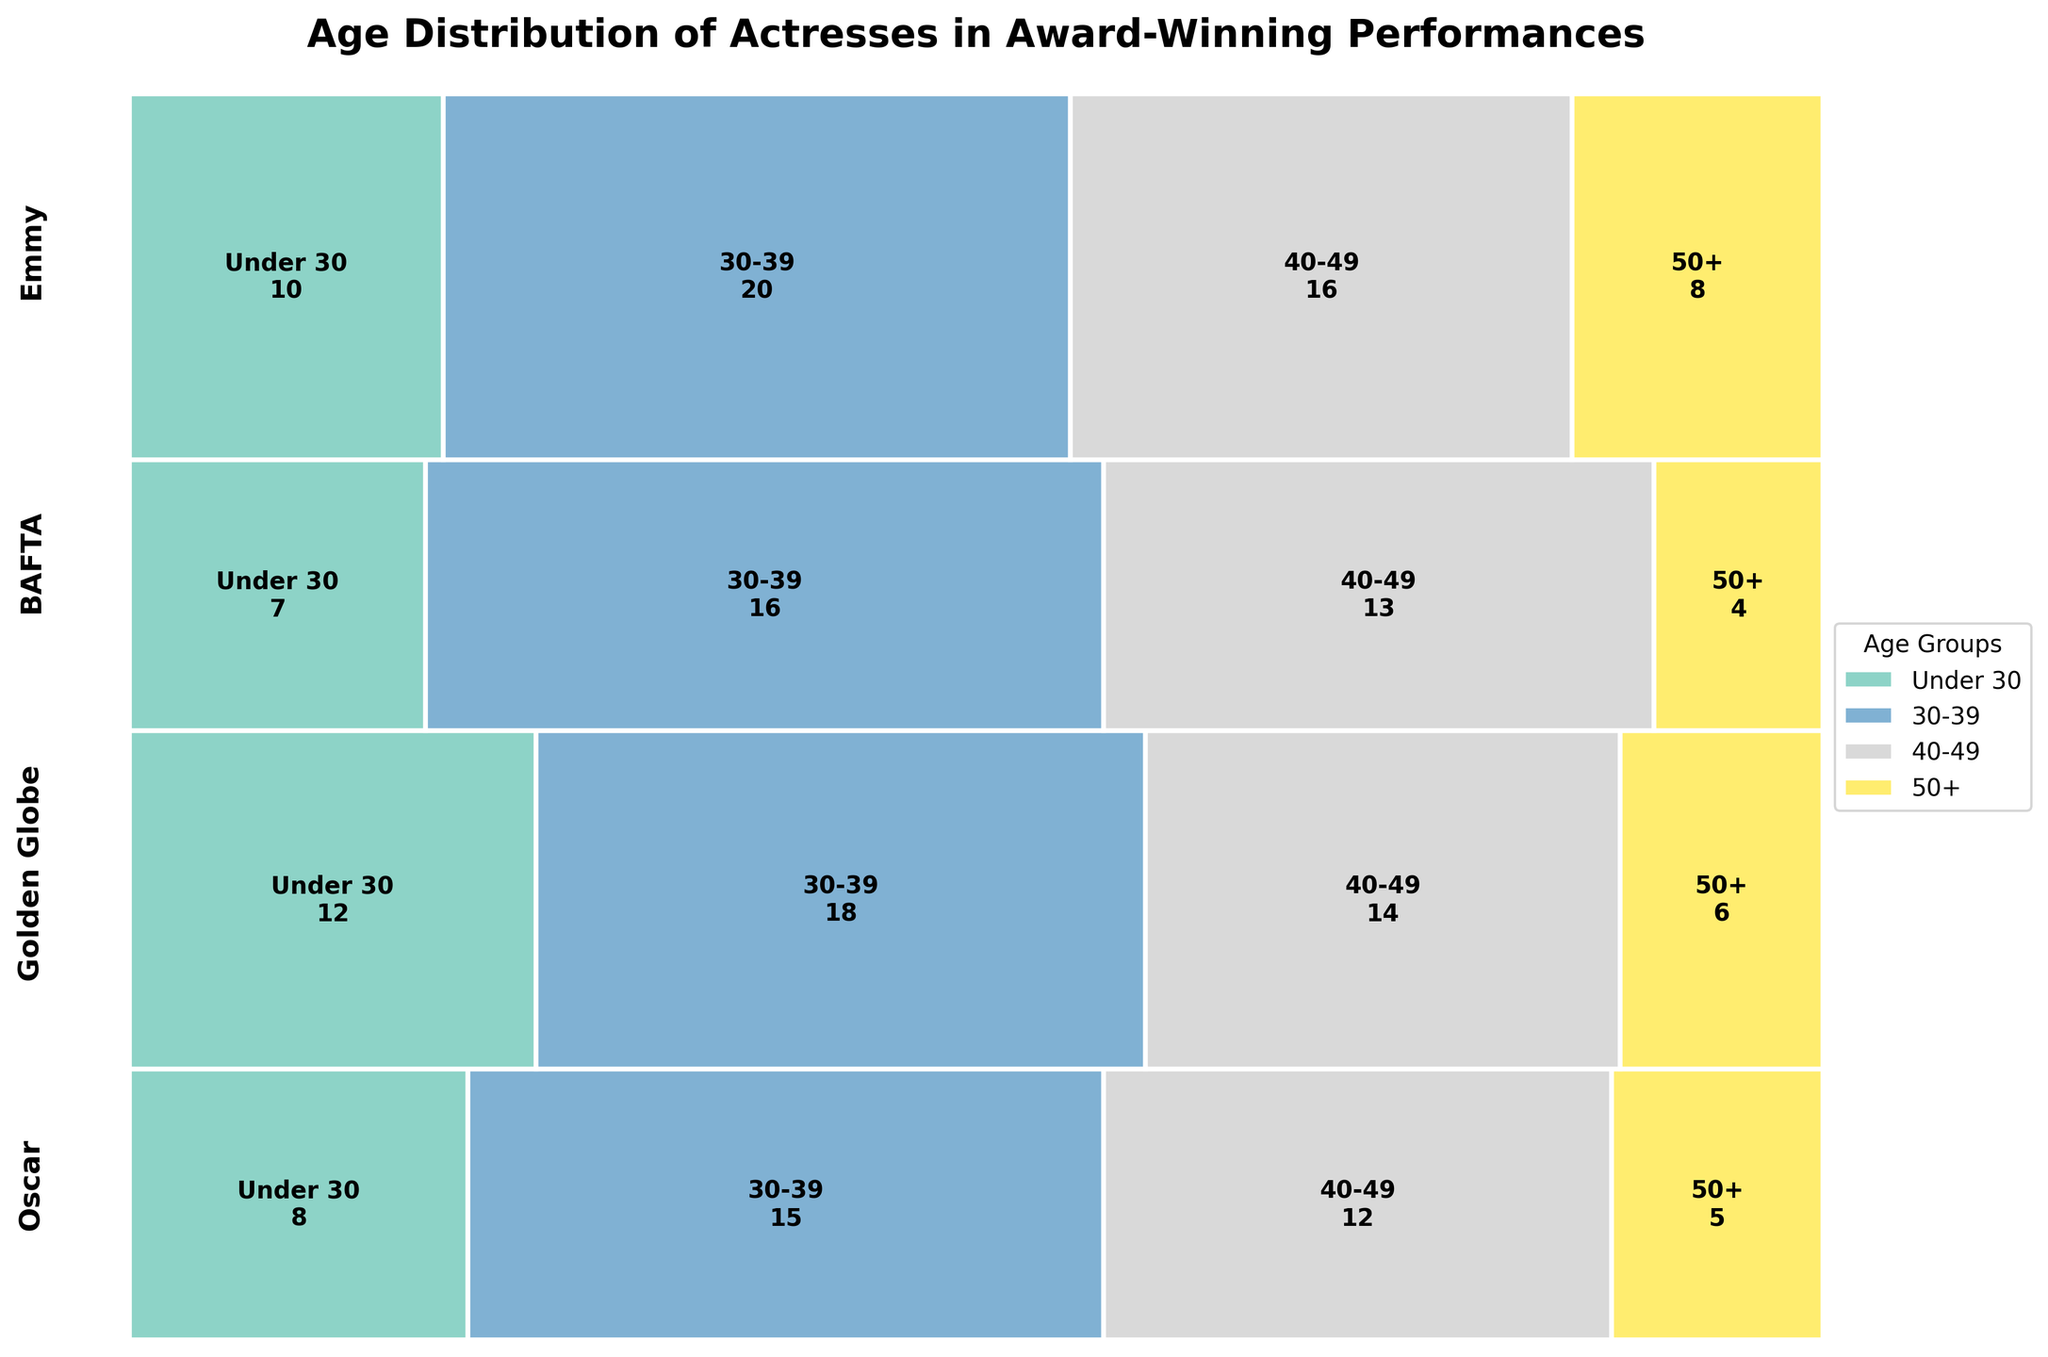How many actresses in the "Under 30" age group won Golden Globes? Look at the "Golden Globe" section of the mosaic plot and find the bar labeled "Under 30" within it. Inside this bar, you can see the count.
Answer: 12 Which award has the highest number of winners in the "30-39" age group? Compare the size of the bars labeled "30-39" across all award sections. The tallest bar represents the award with the highest number of winners.
Answer: Emmy What is the combined total of award-winning actresses in the "50+" age group across all awards? Sum the values of the "50+" age group from each award section: 5 (Oscar) + 6 (Golden Globe) + 4 (BAFTA) +8 (Emmy).
Answer: 23 Which age group has the fewest winners overall? Add the counts for each age group across all awards, then identify the age group with the smallest total.
Answer: 50+ Are there more winners in the "Under 30" or "40-49" age groups for the BAFTA award? Compare the bar labels and their counts within the BAFTA section for both "Under 30" and "40-49" age groups.
Answer: 40-49 What's the proportion of actresses in the "30-39" age group among Oscar winners relative to the total number of Oscar winners? Calculate the percentage: (number of "30-39" winners in Oscar/total number of Oscar winners) x 100. With numbers: (15/40)*100 = 37.5%.
Answer: 37.5% For which award is the "Under 30" age group proportionally largest compared to the other age groups? Check the relative size of the "Under 30" bar in each award section and find which one is the largest proportionally.
Answer: Golden Globe How many more winners are there in the "40-49" age group than in the "Under 30" age group for the Emmy award? Subtract the number of "Under 30" winners from the number of "40-49" winners in the Emmy section: 16 - 10 = 6.
Answer: 6 What percentage of BAFTA winners fall within the "30-39" age group? Calculate using the formula: (number of "30-39" winners in BAFTA/total number of BAFTA winners) x 100. With numbers: (16/40)*100 = 40%.
Answer: 40% Is the number of "50+" age group winners for Emmy more than the combined total of "50+" winners for Oscar and BAFTA? Compare the number of "50+" winners in Emmy (8) with the sum of "50+" winners in Oscar and BAFTA (5 + 4 = 9).
Answer: No 